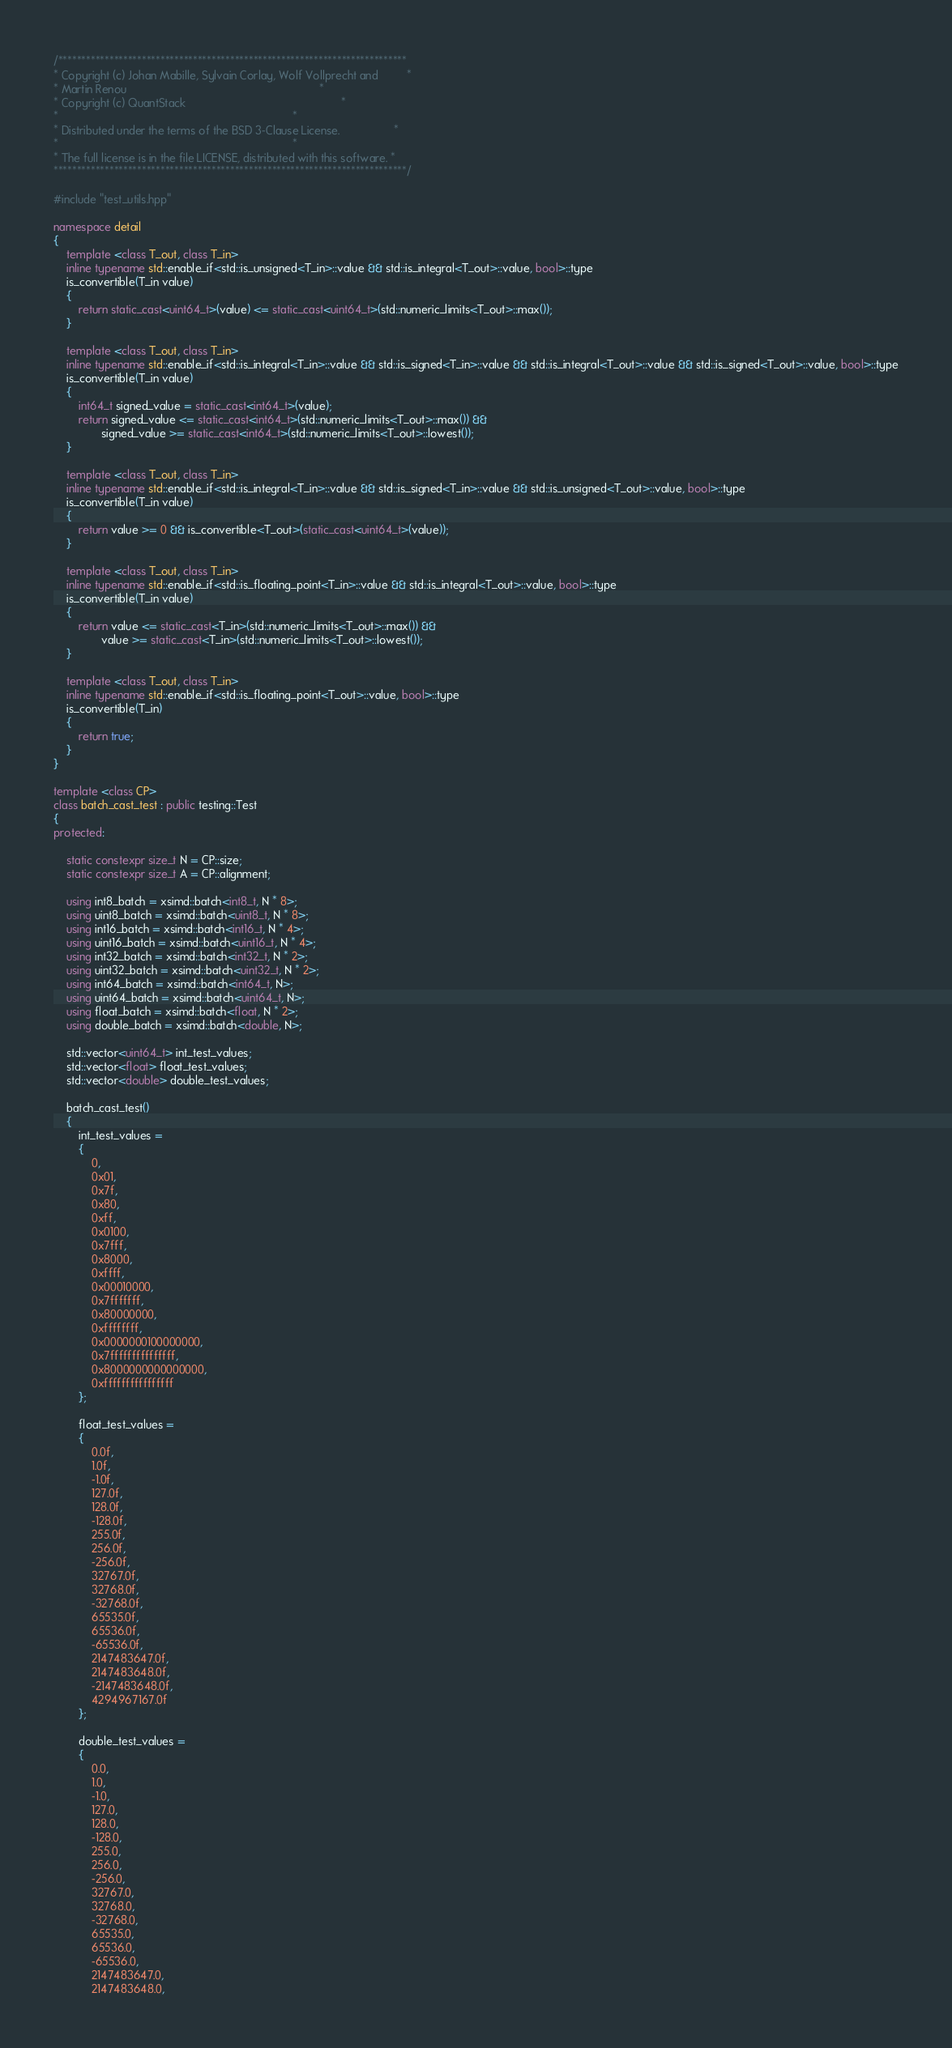<code> <loc_0><loc_0><loc_500><loc_500><_C++_>/***************************************************************************
* Copyright (c) Johan Mabille, Sylvain Corlay, Wolf Vollprecht and         *
* Martin Renou                                                             *
* Copyright (c) QuantStack                                                 *
*                                                                          *
* Distributed under the terms of the BSD 3-Clause License.                 *
*                                                                          *
* The full license is in the file LICENSE, distributed with this software. *
****************************************************************************/

#include "test_utils.hpp"

namespace detail
{
    template <class T_out, class T_in>
    inline typename std::enable_if<std::is_unsigned<T_in>::value && std::is_integral<T_out>::value, bool>::type
    is_convertible(T_in value)
    {
        return static_cast<uint64_t>(value) <= static_cast<uint64_t>(std::numeric_limits<T_out>::max());
    }

    template <class T_out, class T_in>
    inline typename std::enable_if<std::is_integral<T_in>::value && std::is_signed<T_in>::value && std::is_integral<T_out>::value && std::is_signed<T_out>::value, bool>::type
    is_convertible(T_in value)
    {
        int64_t signed_value = static_cast<int64_t>(value);
        return signed_value <= static_cast<int64_t>(std::numeric_limits<T_out>::max()) &&
               signed_value >= static_cast<int64_t>(std::numeric_limits<T_out>::lowest());
    }

    template <class T_out, class T_in>
    inline typename std::enable_if<std::is_integral<T_in>::value && std::is_signed<T_in>::value && std::is_unsigned<T_out>::value, bool>::type
    is_convertible(T_in value)
    {
        return value >= 0 && is_convertible<T_out>(static_cast<uint64_t>(value));
    }

    template <class T_out, class T_in>
    inline typename std::enable_if<std::is_floating_point<T_in>::value && std::is_integral<T_out>::value, bool>::type
    is_convertible(T_in value)
    {
        return value <= static_cast<T_in>(std::numeric_limits<T_out>::max()) &&
               value >= static_cast<T_in>(std::numeric_limits<T_out>::lowest());
    }

    template <class T_out, class T_in>
    inline typename std::enable_if<std::is_floating_point<T_out>::value, bool>::type
    is_convertible(T_in)
    {
        return true;
    }
}

template <class CP>
class batch_cast_test : public testing::Test
{
protected:

    static constexpr size_t N = CP::size;
    static constexpr size_t A = CP::alignment;

    using int8_batch = xsimd::batch<int8_t, N * 8>;
    using uint8_batch = xsimd::batch<uint8_t, N * 8>;
    using int16_batch = xsimd::batch<int16_t, N * 4>;
    using uint16_batch = xsimd::batch<uint16_t, N * 4>;
    using int32_batch = xsimd::batch<int32_t, N * 2>;
    using uint32_batch = xsimd::batch<uint32_t, N * 2>;
    using int64_batch = xsimd::batch<int64_t, N>;
    using uint64_batch = xsimd::batch<uint64_t, N>;
    using float_batch = xsimd::batch<float, N * 2>;
    using double_batch = xsimd::batch<double, N>;

    std::vector<uint64_t> int_test_values;
    std::vector<float> float_test_values;
    std::vector<double> double_test_values;

    batch_cast_test()
    {
        int_test_values =
        {
            0,
            0x01,
            0x7f,
            0x80,
            0xff,
            0x0100,
            0x7fff,
            0x8000,
            0xffff,
            0x00010000,
            0x7fffffff,
            0x80000000,
            0xffffffff,
            0x0000000100000000,
            0x7fffffffffffffff,
            0x8000000000000000,
            0xffffffffffffffff
        };

        float_test_values =
        {
            0.0f,
            1.0f,
            -1.0f,
            127.0f,
            128.0f,
            -128.0f,
            255.0f,
            256.0f,
            -256.0f,
            32767.0f,
            32768.0f,
            -32768.0f,
            65535.0f,
            65536.0f,
            -65536.0f,
            2147483647.0f,
            2147483648.0f,
            -2147483648.0f,
            4294967167.0f
        };

        double_test_values =
        {
            0.0,
            1.0,
            -1.0,
            127.0,
            128.0,
            -128.0,
            255.0,
            256.0,
            -256.0,
            32767.0,
            32768.0,
            -32768.0,
            65535.0,
            65536.0,
            -65536.0,
            2147483647.0,
            2147483648.0,</code> 